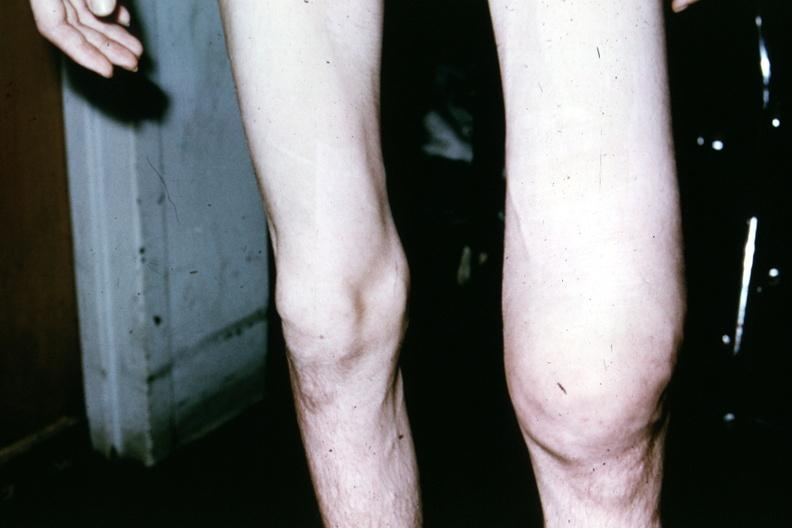what does this image show?
Answer the question using a single word or phrase. Patient before surgery showing both knees 18yo male 